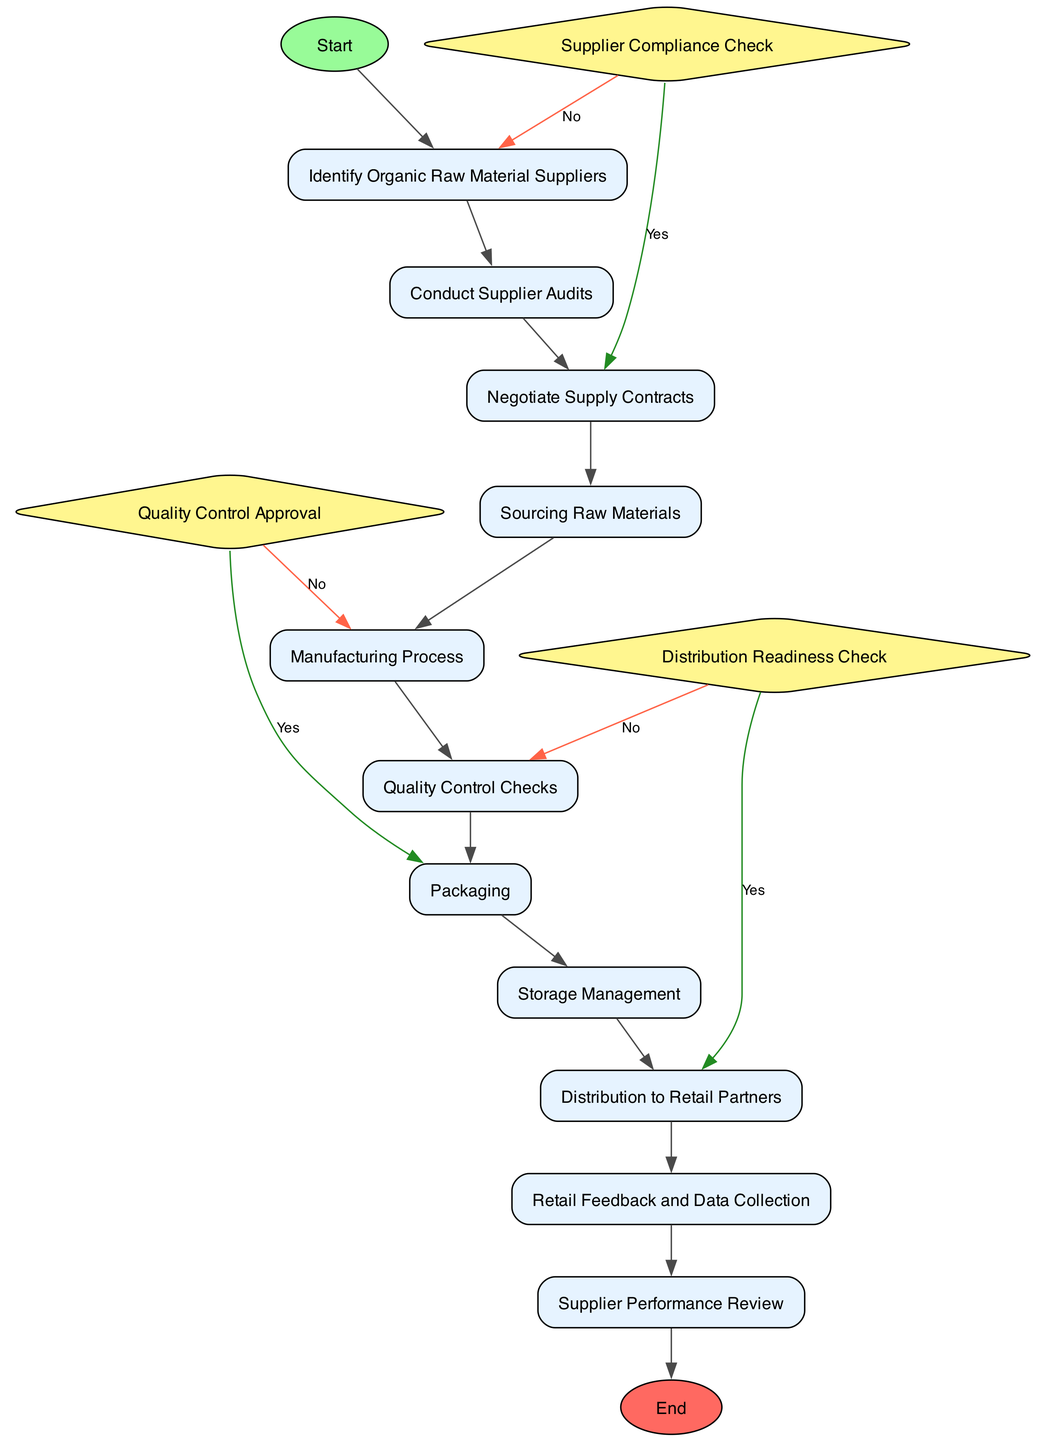What is the starting activity in the diagram? The starting activity is specified in the 'Start' section of the diagram. According to the data provided, the initial activity is "Identify Organic Raw Material Suppliers."
Answer: Identify Organic Raw Material Suppliers How many main activities are listed in the diagram? The diagram details ten activities. These are all the activities specified under the 'Activities' section in the provided data.
Answer: Ten What activity follows "Quality Control Checks"? The diagram indicates that after "Quality Control Checks," the next activity is "Packaging." This can be observed in the 'next' relationship defined in the data.
Answer: Packaging What decision occurs after conducting supplier audits? The decision "Supplier Compliance Check" is evaluated immediately after the "Conduct Supplier Audits" activity. This decision determines the next path based on supplier fidelity.
Answer: Supplier Compliance Check If the quality control checks fail, which activity should be revisited? If the quality control checks fail, the flow directs back to "Manufacturing Process." This is indicated by the 'falseNext' relation from the "Quality Control Approval" decision.
Answer: Manufacturing Process What are the last activities before reaching the end of the diagram? The last two activities before reaching the end are "Retail Feedback and Data Collection" followed by "Supplier Performance Review." This sequence is derived from the flow of the diagram leading to the end point.
Answer: Retail Feedback and Data Collection, Supplier Performance Review What happens if a supplier does not meet organic certification standards? If a supplier does not meet the certification standards, the flow directs back to "Identify Organic Raw Material Suppliers." This is indicated in the "Supplier Compliance Check" decision under the false path.
Answer: Identify Organic Raw Material Suppliers Which activity is linked directly before "Distribution to Retail Partners"? The activity linked directly before "Distribution to Retail Partners" is "Storage Management." This link is established in the sequence of activities flowing into the distribution phase.
Answer: Storage Management How many decisions are present in the diagram? The diagram contains three decisions, as listed under the 'Decisions' section of the data provided.
Answer: Three 